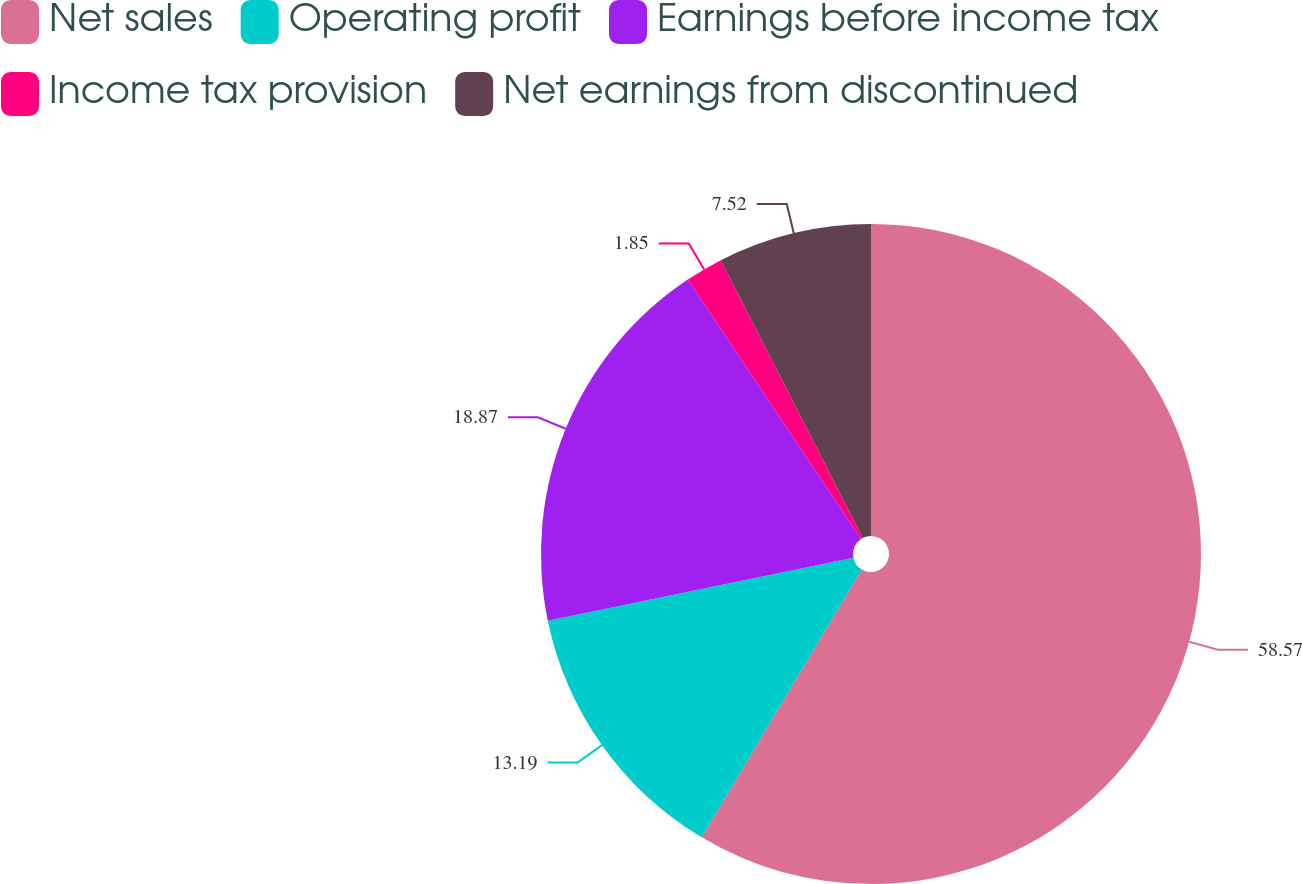<chart> <loc_0><loc_0><loc_500><loc_500><pie_chart><fcel>Net sales<fcel>Operating profit<fcel>Earnings before income tax<fcel>Income tax provision<fcel>Net earnings from discontinued<nl><fcel>58.58%<fcel>13.19%<fcel>18.87%<fcel>1.85%<fcel>7.52%<nl></chart> 